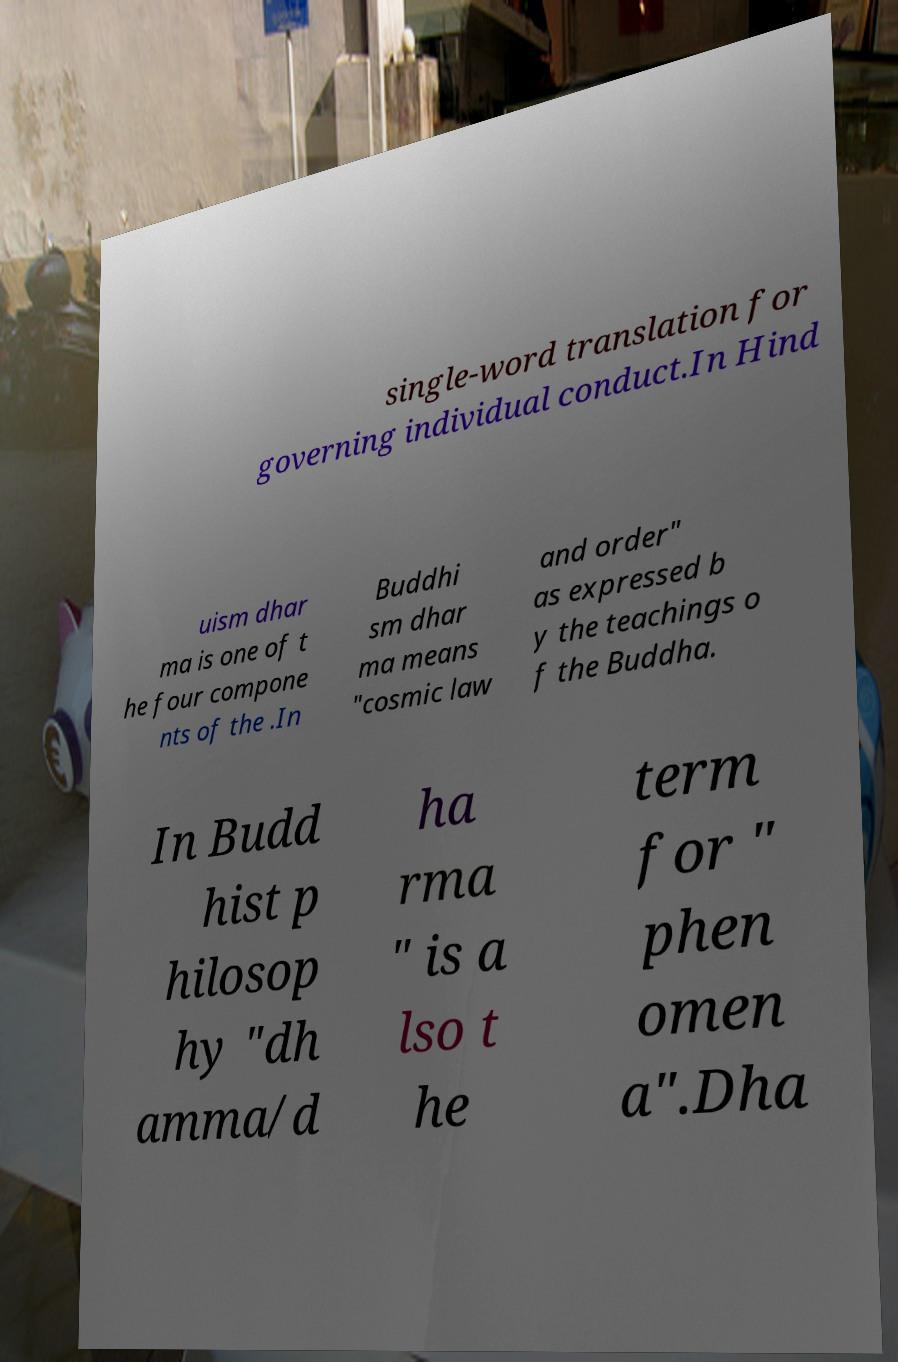Please read and relay the text visible in this image. What does it say? single-word translation for governing individual conduct.In Hind uism dhar ma is one of t he four compone nts of the .In Buddhi sm dhar ma means "cosmic law and order" as expressed b y the teachings o f the Buddha. In Budd hist p hilosop hy "dh amma/d ha rma " is a lso t he term for " phen omen a".Dha 